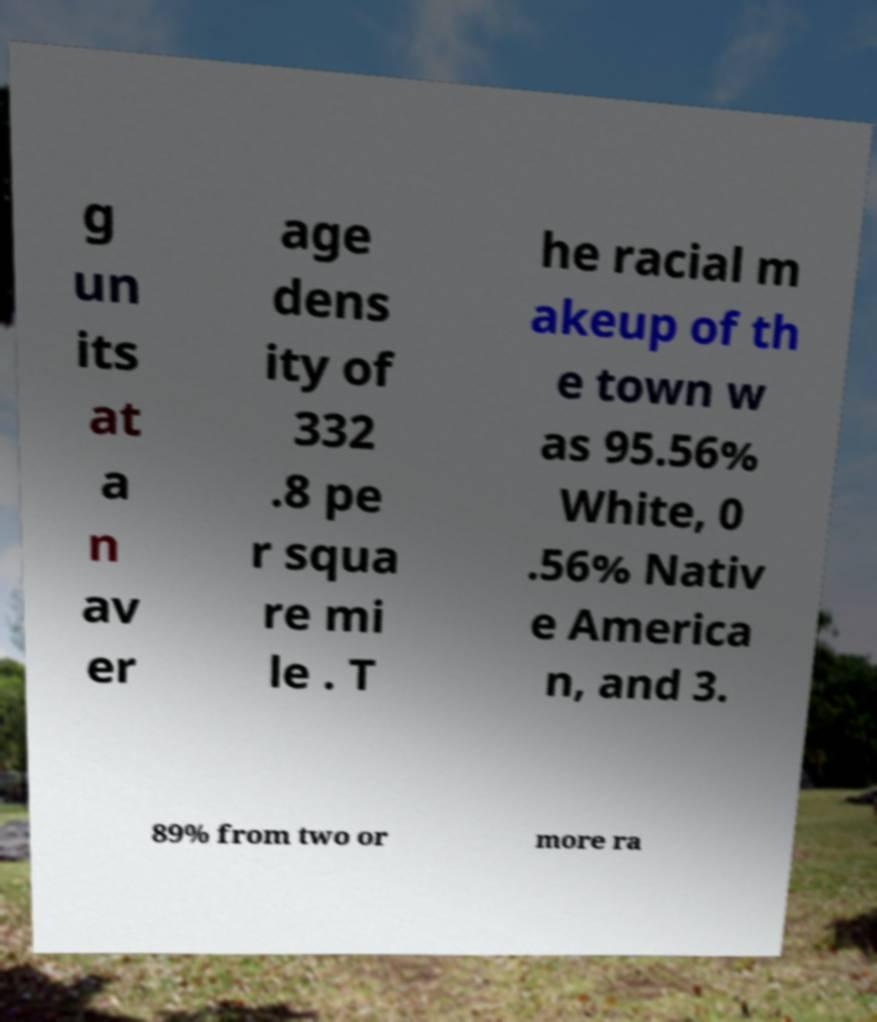Can you read and provide the text displayed in the image?This photo seems to have some interesting text. Can you extract and type it out for me? g un its at a n av er age dens ity of 332 .8 pe r squa re mi le . T he racial m akeup of th e town w as 95.56% White, 0 .56% Nativ e America n, and 3. 89% from two or more ra 